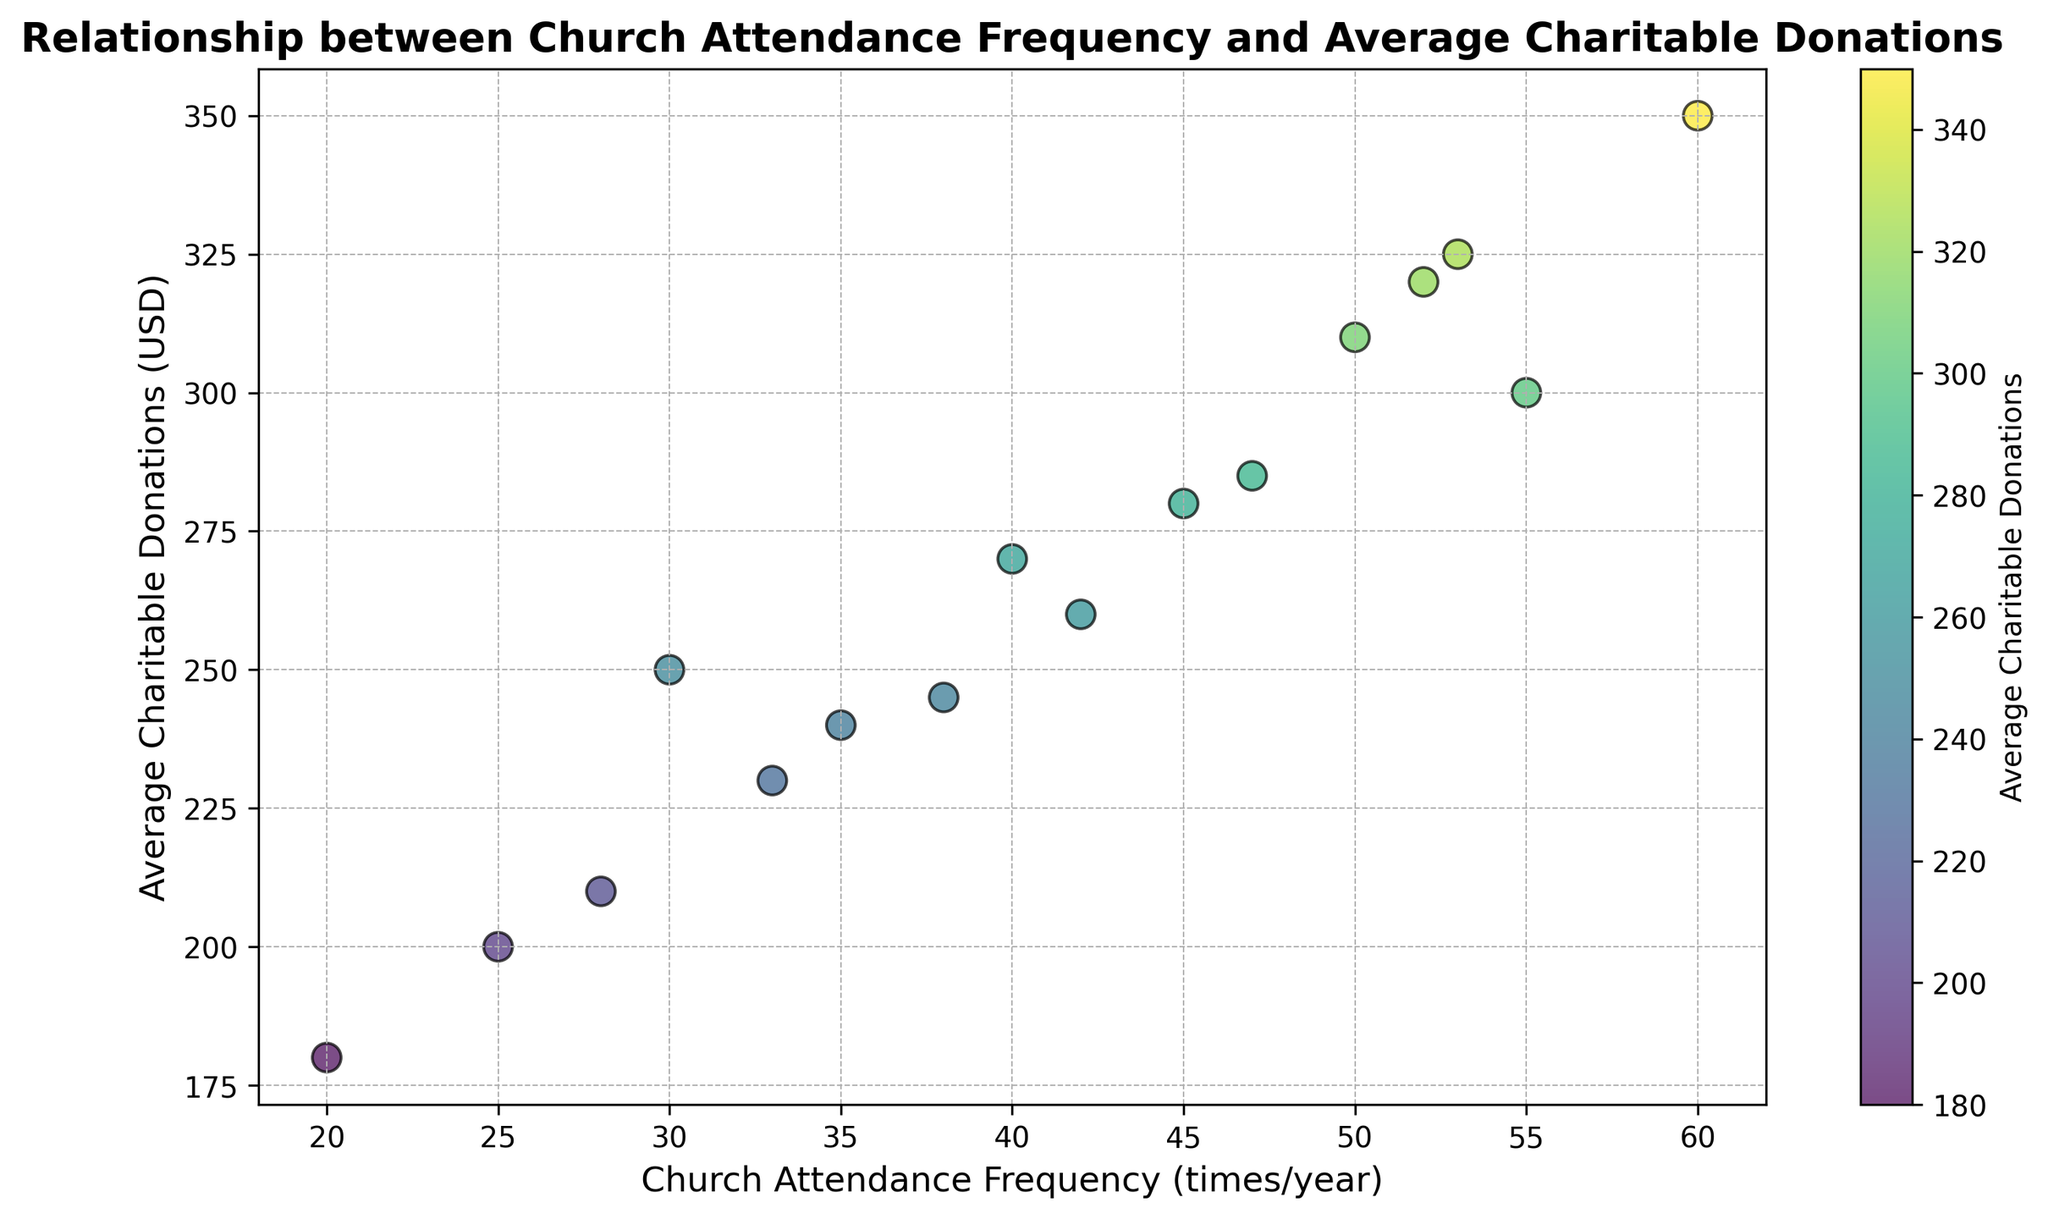What is the relationship between church attendance frequency and average charitable donations? Observing the scatter plot, there is a positive correlation between church attendance frequency and average charitable donations. As church attendance frequency increases, average charitable donations also tend to increase.
Answer: Positive correlation Which diocese has the highest average charitable donation and what is its church attendance frequency? Looking at the scatter plot, Diocese D has the highest average charitable donation at $350, and its church attendance frequency is 60 times per year.
Answer: Diocese D, 60 times/year Compare the average charitable donations between Diocese A and Diocese G. Which one is higher and by how much? From the scatter plot, Diocese G has an average charitable donation of $300 while Diocese A has $250. The difference is $300 - $250 = $50.
Answer: Diocese G, $50 What is the average charitable donation for dioceses with a church attendance frequency greater than 50? From the plot, dioceses with church attendance frequencies greater than 50 are B, D, G, J, and P, with donations of $320, $350, $300, $310, $325 respectively. The average is calculated as (320 + 350 + 300 + 310 + 325)/5 = $321.
Answer: $321 Identify the diocese with the lowest church attendance frequency. What is the average charitable donation for this diocese? The scatter plot shows that Diocese H has the lowest church attendance frequency at 20 times per year, with an average charitable donation of $180.
Answer: Diocese H, $180 Which diocese shows the biggest difference in attendance frequency compared to Diocese K, and what is the difference? Diocese K has an attendance frequency of 42. Diocese H, with an attendance frequency of 20, shows the biggest difference. The difference is 42 - 20 = 22 times per year.
Answer: Diocese H, 22 times/year What is the color representing the highest average charitable donation in the scatter plot? The color bar indicates that the highest average charitable donation is represented by a dark green color.
Answer: Dark green What visual attribute distinguishes Diocese B in the scatter plot? Diocese B is represented by a colored point located at 52 times/year for church attendance frequency and $320 for average charitable donations. The point is marked with an edge color of black and has a medium green shade.
Answer: Medium green with black edge Is Diocese E's average charitable donation below the overall average shown in the scatter plot? To determine this, first find the overall average of all dioceses by summing the donations and dividing by the number of dioceses: (250 + 320 + 280 + 350 + 200 + 270 + 300 + 180 + 240 + 310 + 260 + 230 + 245 + 285 + 210 + 325)/16 = $268. Diocese E's average charitable donation is $200, which is below this overall average.
Answer: Yes What pattern can be observed regarding church attendance frequency and the variation in charitable donations? Observing the scatter plot, as church attendance frequency increases, there seems to be a clustering of higher donations, indicating more consistent higher donations with higher attendance rates. The donations vary widely with lower attendance frequencies.
Answer: Higher attendance shows consistently higher donations 